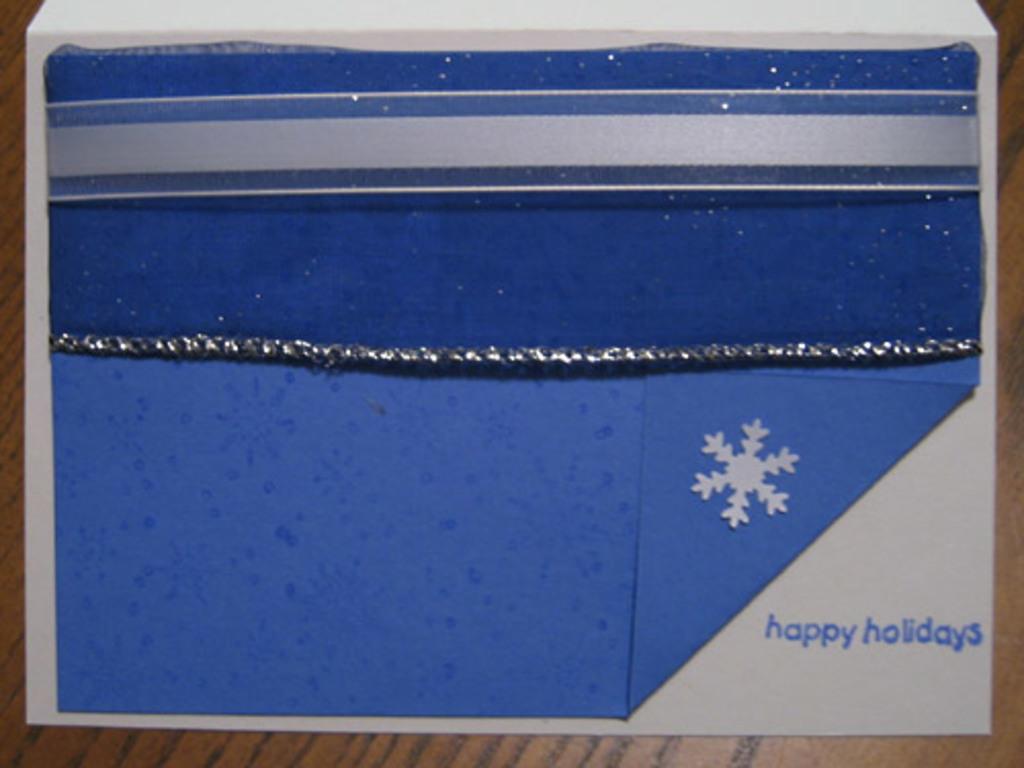What type of holidays does the card say?
Provide a short and direct response. Happy. 